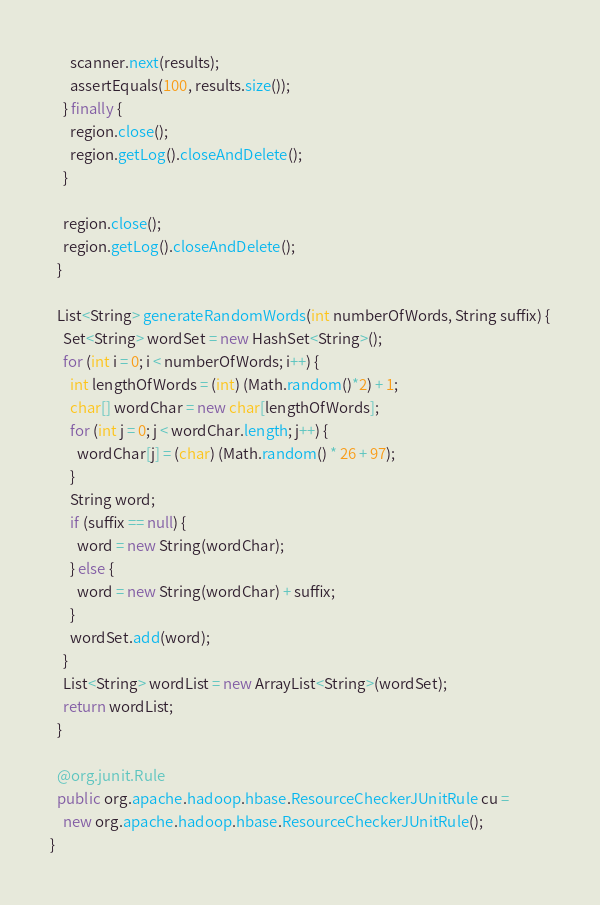<code> <loc_0><loc_0><loc_500><loc_500><_Java_>      scanner.next(results);
      assertEquals(100, results.size());
    } finally {
      region.close();
      region.getLog().closeAndDelete();
    }

    region.close();
    region.getLog().closeAndDelete();
  }

  List<String> generateRandomWords(int numberOfWords, String suffix) {
    Set<String> wordSet = new HashSet<String>();
    for (int i = 0; i < numberOfWords; i++) {
      int lengthOfWords = (int) (Math.random()*2) + 1;
      char[] wordChar = new char[lengthOfWords];
      for (int j = 0; j < wordChar.length; j++) {
        wordChar[j] = (char) (Math.random() * 26 + 97);
      }
      String word;
      if (suffix == null) {
        word = new String(wordChar);
      } else {
        word = new String(wordChar) + suffix;
      }
      wordSet.add(word);
    }
    List<String> wordList = new ArrayList<String>(wordSet);
    return wordList;
  }

  @org.junit.Rule
  public org.apache.hadoop.hbase.ResourceCheckerJUnitRule cu =
    new org.apache.hadoop.hbase.ResourceCheckerJUnitRule();
}

</code> 